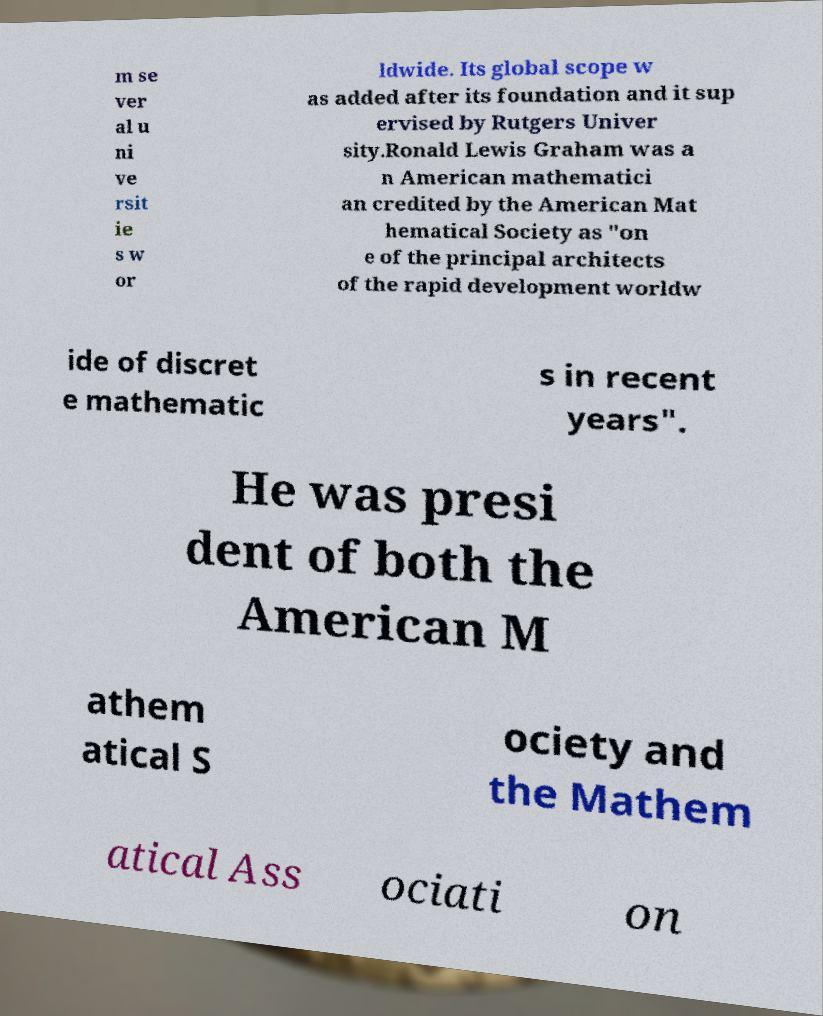For documentation purposes, I need the text within this image transcribed. Could you provide that? m se ver al u ni ve rsit ie s w or ldwide. Its global scope w as added after its foundation and it sup ervised by Rutgers Univer sity.Ronald Lewis Graham was a n American mathematici an credited by the American Mat hematical Society as "on e of the principal architects of the rapid development worldw ide of discret e mathematic s in recent years". He was presi dent of both the American M athem atical S ociety and the Mathem atical Ass ociati on 